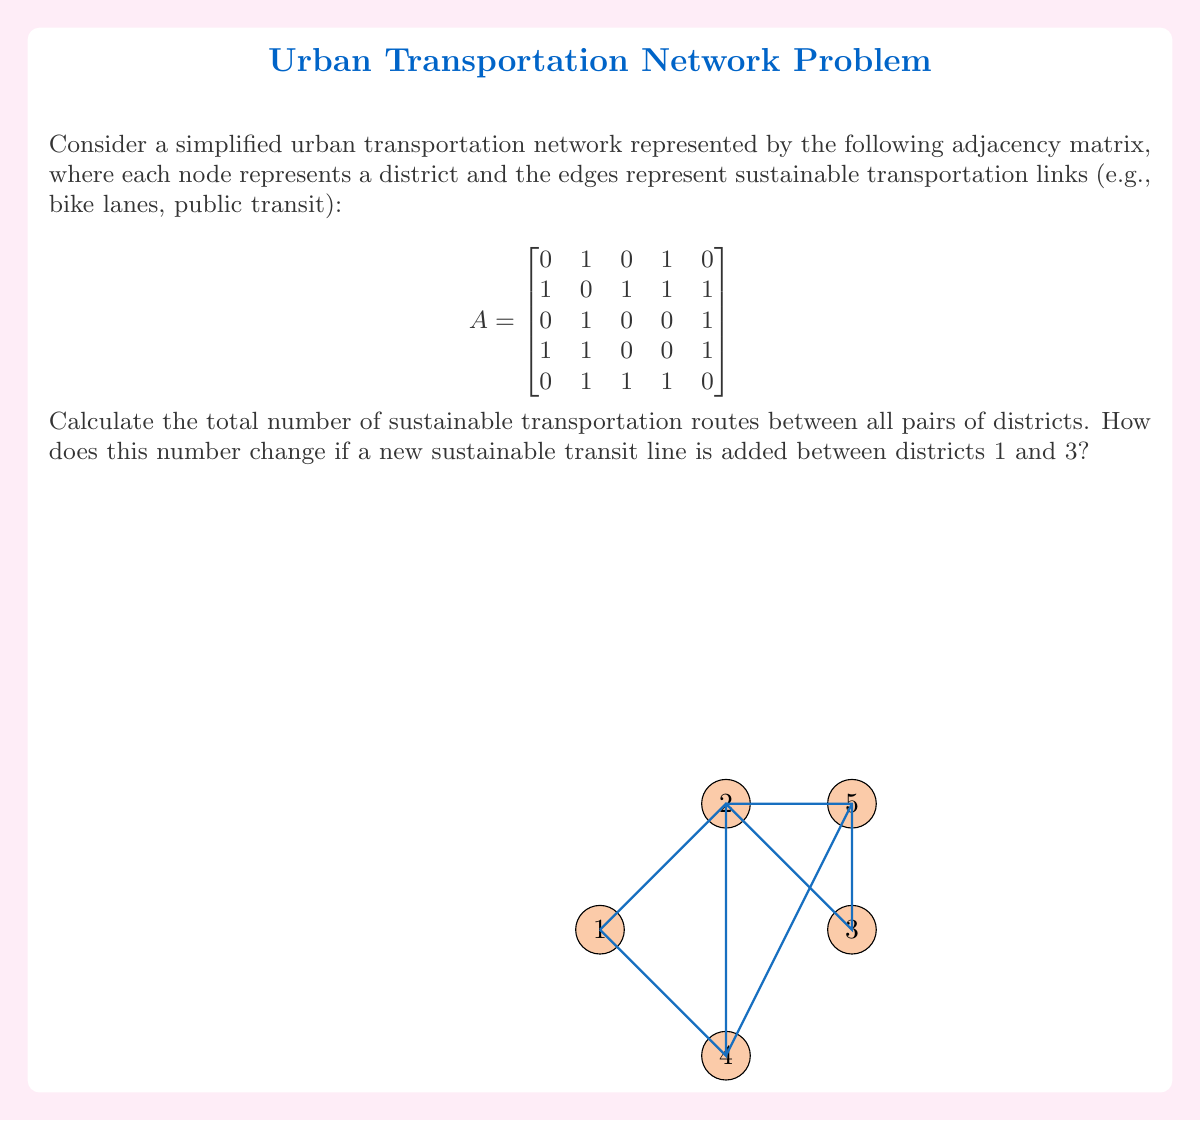Solve this math problem. Let's approach this step-by-step:

1) In graph theory, the total number of paths between all pairs of nodes is given by the sum of all elements in the matrix $(A + A^2 + A^3 + ... + A^{n-1})$, where $n$ is the number of nodes.

2) For our 5x5 matrix, we need to calculate $A + A^2 + A^3 + A^4$.

3) Let's calculate each power:

   $A^2 = \begin{bmatrix}
   2 & 1 & 1 & 1 & 2 \\
   1 & 4 & 2 & 2 & 2 \\
   1 & 2 & 2 & 2 & 1 \\
   1 & 2 & 2 & 3 & 1 \\
   2 & 2 & 1 & 1 & 3
   \end{bmatrix}$

   $A^3 = \begin{bmatrix}
   1 & 4 & 2 & 2 & 2 \\
   4 & 4 & 4 & 5 & 5 \\
   2 & 4 & 2 & 2 & 3 \\
   2 & 5 & 2 & 2 & 4 \\
   2 & 5 & 3 & 4 & 2
   \end{bmatrix}$

   $A^4 = \begin{bmatrix}
   4 & 4 & 4 & 5 & 5 \\
   4 & 13 & 7 & 8 & 9 \\
   4 & 7 & 5 & 6 & 5 \\
   5 & 8 & 6 & 8 & 6 \\
   5 & 9 & 5 & 6 & 9
   \end{bmatrix}$

4) Now, we sum all these matrices:

   $A + A^2 + A^3 + A^4 = \begin{bmatrix}
   7 & 10 & 7 & 9 & 9 \\
   10 & 21 & 14 & 16 & 17 \\
   7 & 14 & 9 & 10 & 10 \\
   9 & 16 & 10 & 13 & 12 \\
   9 & 17 & 10 & 12 & 14
   \end{bmatrix}$

5) The sum of all elements in this matrix is 270. This is the total number of routes between all pairs of districts.

6) If we add a new link between districts 1 and 3, the adjacency matrix becomes:

   $A_{new} = \begin{bmatrix}
   0 & 1 & 1 & 1 & 0 \\
   1 & 0 & 1 & 1 & 1 \\
   1 & 1 & 0 & 0 & 1 \\
   1 & 1 & 0 & 0 & 1 \\
   0 & 1 & 1 & 1 & 0
   \end{bmatrix}$

7) Repeating the process with this new matrix, we get:

   $A_{new} + A_{new}^2 + A_{new}^3 + A_{new}^4 = \begin{bmatrix}
   9 & 12 & 9 & 11 & 11 \\
   12 & 21 & 14 & 16 & 17 \\
   9 & 14 & 11 & 12 & 12 \\
   11 & 16 & 12 & 15 & 14 \\
   11 & 17 & 12 & 14 & 16
   \end{bmatrix}$

8) The sum of all elements in this new matrix is 306.

Therefore, adding the new link increases the total number of routes by 306 - 270 = 36.
Answer: 270 routes; increases by 36 to 306 routes 